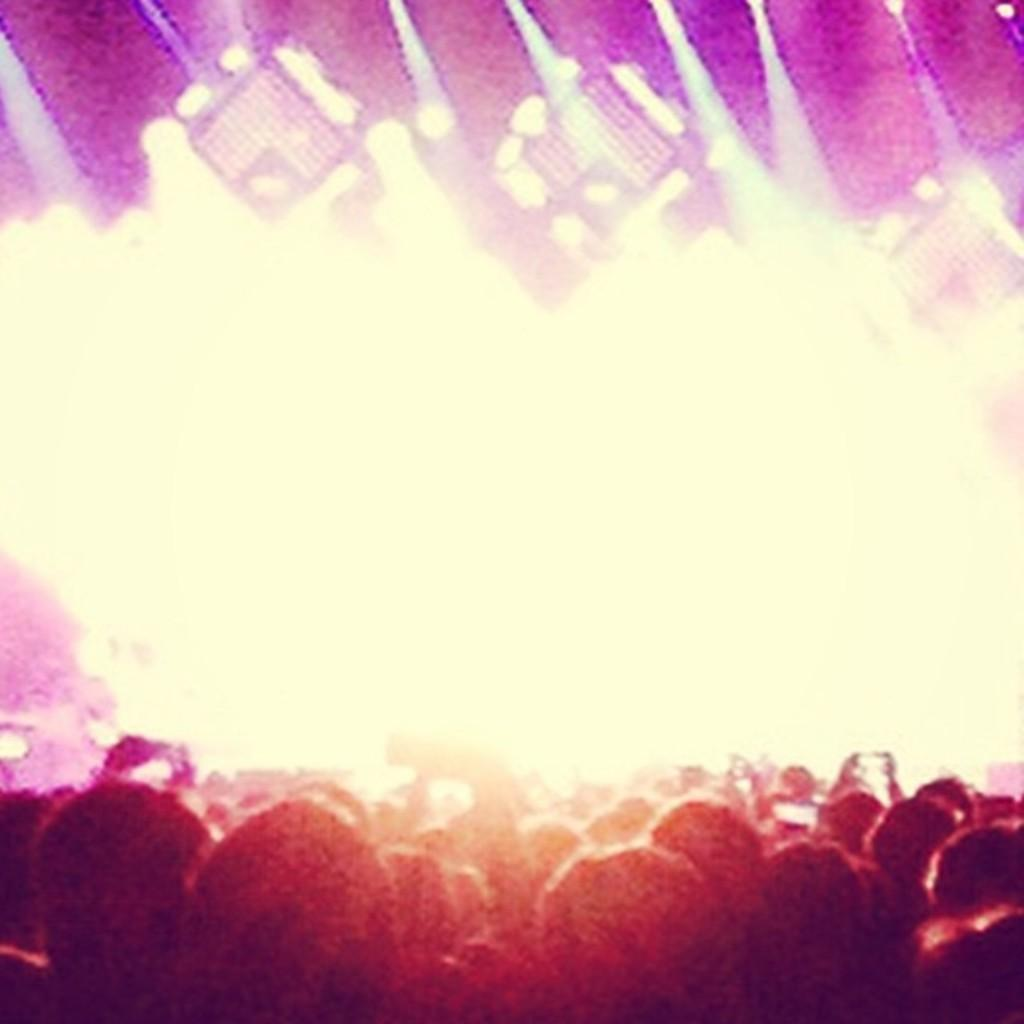What is happening in the foreground of the image? There is a group of people standing in the foreground of the image. Can you describe any specific actions or objects being held by the people? One person is holding a mobile in his hand. What can be seen in the background of the image? There are lights visible in the background of the image. How many deer are visible in the image? There are no deer present in the image. What type of reward is being given to the person holding the mobile? There is no reward being given in the image; the person is simply holding a mobile. 